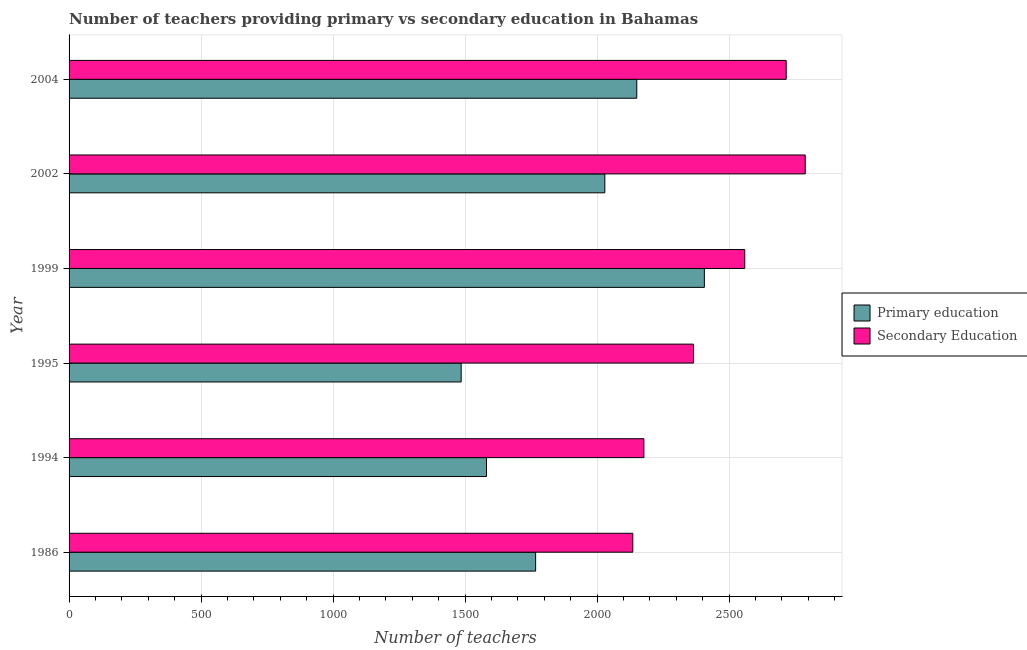How many different coloured bars are there?
Your response must be concise. 2. How many groups of bars are there?
Your answer should be compact. 6. Are the number of bars on each tick of the Y-axis equal?
Offer a terse response. Yes. How many bars are there on the 4th tick from the top?
Your answer should be compact. 2. How many bars are there on the 3rd tick from the bottom?
Provide a short and direct response. 2. What is the number of primary teachers in 1994?
Keep it short and to the point. 1581. Across all years, what is the maximum number of primary teachers?
Your answer should be compact. 2406. Across all years, what is the minimum number of primary teachers?
Provide a succinct answer. 1485. In which year was the number of primary teachers maximum?
Your answer should be compact. 1999. In which year was the number of primary teachers minimum?
Provide a short and direct response. 1995. What is the total number of primary teachers in the graph?
Provide a short and direct response. 1.14e+04. What is the difference between the number of secondary teachers in 1986 and that in 1994?
Ensure brevity in your answer.  -42. What is the difference between the number of secondary teachers in 2004 and the number of primary teachers in 1986?
Your answer should be very brief. 949. What is the average number of primary teachers per year?
Give a very brief answer. 1903. In the year 2002, what is the difference between the number of secondary teachers and number of primary teachers?
Your answer should be very brief. 759. What is the ratio of the number of primary teachers in 1994 to that in 2002?
Make the answer very short. 0.78. Is the number of primary teachers in 1999 less than that in 2004?
Offer a terse response. No. Is the difference between the number of primary teachers in 1995 and 2002 greater than the difference between the number of secondary teachers in 1995 and 2002?
Your answer should be compact. No. What is the difference between the highest and the second highest number of secondary teachers?
Offer a terse response. 72. What is the difference between the highest and the lowest number of secondary teachers?
Provide a short and direct response. 653. In how many years, is the number of primary teachers greater than the average number of primary teachers taken over all years?
Offer a very short reply. 3. What does the 1st bar from the bottom in 1999 represents?
Your answer should be compact. Primary education. How many bars are there?
Your answer should be very brief. 12. Does the graph contain any zero values?
Ensure brevity in your answer.  No. Where does the legend appear in the graph?
Keep it short and to the point. Center right. How are the legend labels stacked?
Provide a short and direct response. Vertical. What is the title of the graph?
Keep it short and to the point. Number of teachers providing primary vs secondary education in Bahamas. Does "Diarrhea" appear as one of the legend labels in the graph?
Give a very brief answer. No. What is the label or title of the X-axis?
Make the answer very short. Number of teachers. What is the Number of teachers of Primary education in 1986?
Provide a short and direct response. 1767. What is the Number of teachers of Secondary Education in 1986?
Make the answer very short. 2135. What is the Number of teachers of Primary education in 1994?
Offer a terse response. 1581. What is the Number of teachers of Secondary Education in 1994?
Provide a short and direct response. 2177. What is the Number of teachers in Primary education in 1995?
Your response must be concise. 1485. What is the Number of teachers in Secondary Education in 1995?
Ensure brevity in your answer.  2365. What is the Number of teachers of Primary education in 1999?
Provide a short and direct response. 2406. What is the Number of teachers of Secondary Education in 1999?
Ensure brevity in your answer.  2559. What is the Number of teachers of Primary education in 2002?
Offer a very short reply. 2029. What is the Number of teachers of Secondary Education in 2002?
Provide a short and direct response. 2788. What is the Number of teachers of Primary education in 2004?
Keep it short and to the point. 2150. What is the Number of teachers in Secondary Education in 2004?
Give a very brief answer. 2716. Across all years, what is the maximum Number of teachers of Primary education?
Provide a short and direct response. 2406. Across all years, what is the maximum Number of teachers of Secondary Education?
Offer a very short reply. 2788. Across all years, what is the minimum Number of teachers in Primary education?
Provide a succinct answer. 1485. Across all years, what is the minimum Number of teachers in Secondary Education?
Offer a very short reply. 2135. What is the total Number of teachers in Primary education in the graph?
Keep it short and to the point. 1.14e+04. What is the total Number of teachers of Secondary Education in the graph?
Your answer should be compact. 1.47e+04. What is the difference between the Number of teachers in Primary education in 1986 and that in 1994?
Keep it short and to the point. 186. What is the difference between the Number of teachers in Secondary Education in 1986 and that in 1994?
Offer a very short reply. -42. What is the difference between the Number of teachers in Primary education in 1986 and that in 1995?
Your answer should be compact. 282. What is the difference between the Number of teachers in Secondary Education in 1986 and that in 1995?
Offer a very short reply. -230. What is the difference between the Number of teachers of Primary education in 1986 and that in 1999?
Keep it short and to the point. -639. What is the difference between the Number of teachers of Secondary Education in 1986 and that in 1999?
Your answer should be compact. -424. What is the difference between the Number of teachers in Primary education in 1986 and that in 2002?
Ensure brevity in your answer.  -262. What is the difference between the Number of teachers in Secondary Education in 1986 and that in 2002?
Offer a terse response. -653. What is the difference between the Number of teachers of Primary education in 1986 and that in 2004?
Your answer should be very brief. -383. What is the difference between the Number of teachers of Secondary Education in 1986 and that in 2004?
Provide a succinct answer. -581. What is the difference between the Number of teachers of Primary education in 1994 and that in 1995?
Give a very brief answer. 96. What is the difference between the Number of teachers of Secondary Education in 1994 and that in 1995?
Give a very brief answer. -188. What is the difference between the Number of teachers of Primary education in 1994 and that in 1999?
Give a very brief answer. -825. What is the difference between the Number of teachers of Secondary Education in 1994 and that in 1999?
Make the answer very short. -382. What is the difference between the Number of teachers of Primary education in 1994 and that in 2002?
Offer a very short reply. -448. What is the difference between the Number of teachers of Secondary Education in 1994 and that in 2002?
Offer a terse response. -611. What is the difference between the Number of teachers in Primary education in 1994 and that in 2004?
Your answer should be very brief. -569. What is the difference between the Number of teachers of Secondary Education in 1994 and that in 2004?
Your answer should be compact. -539. What is the difference between the Number of teachers of Primary education in 1995 and that in 1999?
Give a very brief answer. -921. What is the difference between the Number of teachers of Secondary Education in 1995 and that in 1999?
Provide a short and direct response. -194. What is the difference between the Number of teachers of Primary education in 1995 and that in 2002?
Give a very brief answer. -544. What is the difference between the Number of teachers in Secondary Education in 1995 and that in 2002?
Offer a very short reply. -423. What is the difference between the Number of teachers in Primary education in 1995 and that in 2004?
Provide a succinct answer. -665. What is the difference between the Number of teachers in Secondary Education in 1995 and that in 2004?
Give a very brief answer. -351. What is the difference between the Number of teachers in Primary education in 1999 and that in 2002?
Provide a short and direct response. 377. What is the difference between the Number of teachers in Secondary Education in 1999 and that in 2002?
Your response must be concise. -229. What is the difference between the Number of teachers of Primary education in 1999 and that in 2004?
Make the answer very short. 256. What is the difference between the Number of teachers in Secondary Education in 1999 and that in 2004?
Your answer should be compact. -157. What is the difference between the Number of teachers of Primary education in 2002 and that in 2004?
Offer a very short reply. -121. What is the difference between the Number of teachers in Secondary Education in 2002 and that in 2004?
Offer a terse response. 72. What is the difference between the Number of teachers in Primary education in 1986 and the Number of teachers in Secondary Education in 1994?
Offer a very short reply. -410. What is the difference between the Number of teachers of Primary education in 1986 and the Number of teachers of Secondary Education in 1995?
Ensure brevity in your answer.  -598. What is the difference between the Number of teachers of Primary education in 1986 and the Number of teachers of Secondary Education in 1999?
Your answer should be very brief. -792. What is the difference between the Number of teachers in Primary education in 1986 and the Number of teachers in Secondary Education in 2002?
Make the answer very short. -1021. What is the difference between the Number of teachers of Primary education in 1986 and the Number of teachers of Secondary Education in 2004?
Offer a terse response. -949. What is the difference between the Number of teachers of Primary education in 1994 and the Number of teachers of Secondary Education in 1995?
Your answer should be very brief. -784. What is the difference between the Number of teachers of Primary education in 1994 and the Number of teachers of Secondary Education in 1999?
Provide a succinct answer. -978. What is the difference between the Number of teachers in Primary education in 1994 and the Number of teachers in Secondary Education in 2002?
Your response must be concise. -1207. What is the difference between the Number of teachers of Primary education in 1994 and the Number of teachers of Secondary Education in 2004?
Your answer should be very brief. -1135. What is the difference between the Number of teachers of Primary education in 1995 and the Number of teachers of Secondary Education in 1999?
Provide a short and direct response. -1074. What is the difference between the Number of teachers of Primary education in 1995 and the Number of teachers of Secondary Education in 2002?
Ensure brevity in your answer.  -1303. What is the difference between the Number of teachers of Primary education in 1995 and the Number of teachers of Secondary Education in 2004?
Provide a short and direct response. -1231. What is the difference between the Number of teachers in Primary education in 1999 and the Number of teachers in Secondary Education in 2002?
Offer a terse response. -382. What is the difference between the Number of teachers of Primary education in 1999 and the Number of teachers of Secondary Education in 2004?
Your answer should be very brief. -310. What is the difference between the Number of teachers of Primary education in 2002 and the Number of teachers of Secondary Education in 2004?
Your response must be concise. -687. What is the average Number of teachers in Primary education per year?
Ensure brevity in your answer.  1903. What is the average Number of teachers in Secondary Education per year?
Your response must be concise. 2456.67. In the year 1986, what is the difference between the Number of teachers of Primary education and Number of teachers of Secondary Education?
Offer a terse response. -368. In the year 1994, what is the difference between the Number of teachers of Primary education and Number of teachers of Secondary Education?
Keep it short and to the point. -596. In the year 1995, what is the difference between the Number of teachers of Primary education and Number of teachers of Secondary Education?
Your answer should be very brief. -880. In the year 1999, what is the difference between the Number of teachers of Primary education and Number of teachers of Secondary Education?
Provide a succinct answer. -153. In the year 2002, what is the difference between the Number of teachers of Primary education and Number of teachers of Secondary Education?
Provide a succinct answer. -759. In the year 2004, what is the difference between the Number of teachers in Primary education and Number of teachers in Secondary Education?
Offer a very short reply. -566. What is the ratio of the Number of teachers of Primary education in 1986 to that in 1994?
Give a very brief answer. 1.12. What is the ratio of the Number of teachers in Secondary Education in 1986 to that in 1994?
Keep it short and to the point. 0.98. What is the ratio of the Number of teachers of Primary education in 1986 to that in 1995?
Your answer should be very brief. 1.19. What is the ratio of the Number of teachers of Secondary Education in 1986 to that in 1995?
Keep it short and to the point. 0.9. What is the ratio of the Number of teachers in Primary education in 1986 to that in 1999?
Keep it short and to the point. 0.73. What is the ratio of the Number of teachers in Secondary Education in 1986 to that in 1999?
Make the answer very short. 0.83. What is the ratio of the Number of teachers in Primary education in 1986 to that in 2002?
Your answer should be very brief. 0.87. What is the ratio of the Number of teachers in Secondary Education in 1986 to that in 2002?
Your answer should be compact. 0.77. What is the ratio of the Number of teachers of Primary education in 1986 to that in 2004?
Offer a terse response. 0.82. What is the ratio of the Number of teachers of Secondary Education in 1986 to that in 2004?
Keep it short and to the point. 0.79. What is the ratio of the Number of teachers of Primary education in 1994 to that in 1995?
Offer a very short reply. 1.06. What is the ratio of the Number of teachers of Secondary Education in 1994 to that in 1995?
Ensure brevity in your answer.  0.92. What is the ratio of the Number of teachers in Primary education in 1994 to that in 1999?
Keep it short and to the point. 0.66. What is the ratio of the Number of teachers of Secondary Education in 1994 to that in 1999?
Offer a terse response. 0.85. What is the ratio of the Number of teachers of Primary education in 1994 to that in 2002?
Your response must be concise. 0.78. What is the ratio of the Number of teachers in Secondary Education in 1994 to that in 2002?
Offer a very short reply. 0.78. What is the ratio of the Number of teachers in Primary education in 1994 to that in 2004?
Offer a very short reply. 0.74. What is the ratio of the Number of teachers of Secondary Education in 1994 to that in 2004?
Make the answer very short. 0.8. What is the ratio of the Number of teachers in Primary education in 1995 to that in 1999?
Your response must be concise. 0.62. What is the ratio of the Number of teachers of Secondary Education in 1995 to that in 1999?
Offer a terse response. 0.92. What is the ratio of the Number of teachers in Primary education in 1995 to that in 2002?
Your response must be concise. 0.73. What is the ratio of the Number of teachers in Secondary Education in 1995 to that in 2002?
Keep it short and to the point. 0.85. What is the ratio of the Number of teachers in Primary education in 1995 to that in 2004?
Offer a very short reply. 0.69. What is the ratio of the Number of teachers in Secondary Education in 1995 to that in 2004?
Provide a short and direct response. 0.87. What is the ratio of the Number of teachers in Primary education in 1999 to that in 2002?
Your response must be concise. 1.19. What is the ratio of the Number of teachers in Secondary Education in 1999 to that in 2002?
Your response must be concise. 0.92. What is the ratio of the Number of teachers of Primary education in 1999 to that in 2004?
Provide a short and direct response. 1.12. What is the ratio of the Number of teachers in Secondary Education in 1999 to that in 2004?
Give a very brief answer. 0.94. What is the ratio of the Number of teachers in Primary education in 2002 to that in 2004?
Make the answer very short. 0.94. What is the ratio of the Number of teachers in Secondary Education in 2002 to that in 2004?
Provide a succinct answer. 1.03. What is the difference between the highest and the second highest Number of teachers of Primary education?
Make the answer very short. 256. What is the difference between the highest and the lowest Number of teachers of Primary education?
Make the answer very short. 921. What is the difference between the highest and the lowest Number of teachers in Secondary Education?
Offer a very short reply. 653. 